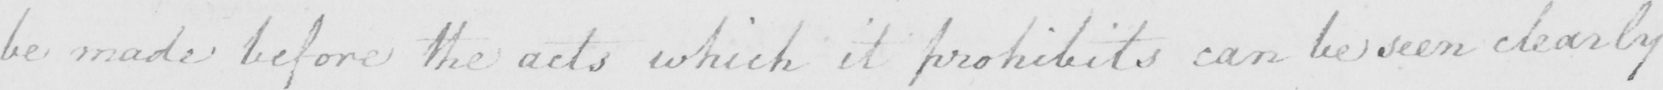What does this handwritten line say? be made before the acts which it prohibits can be seen clearly 